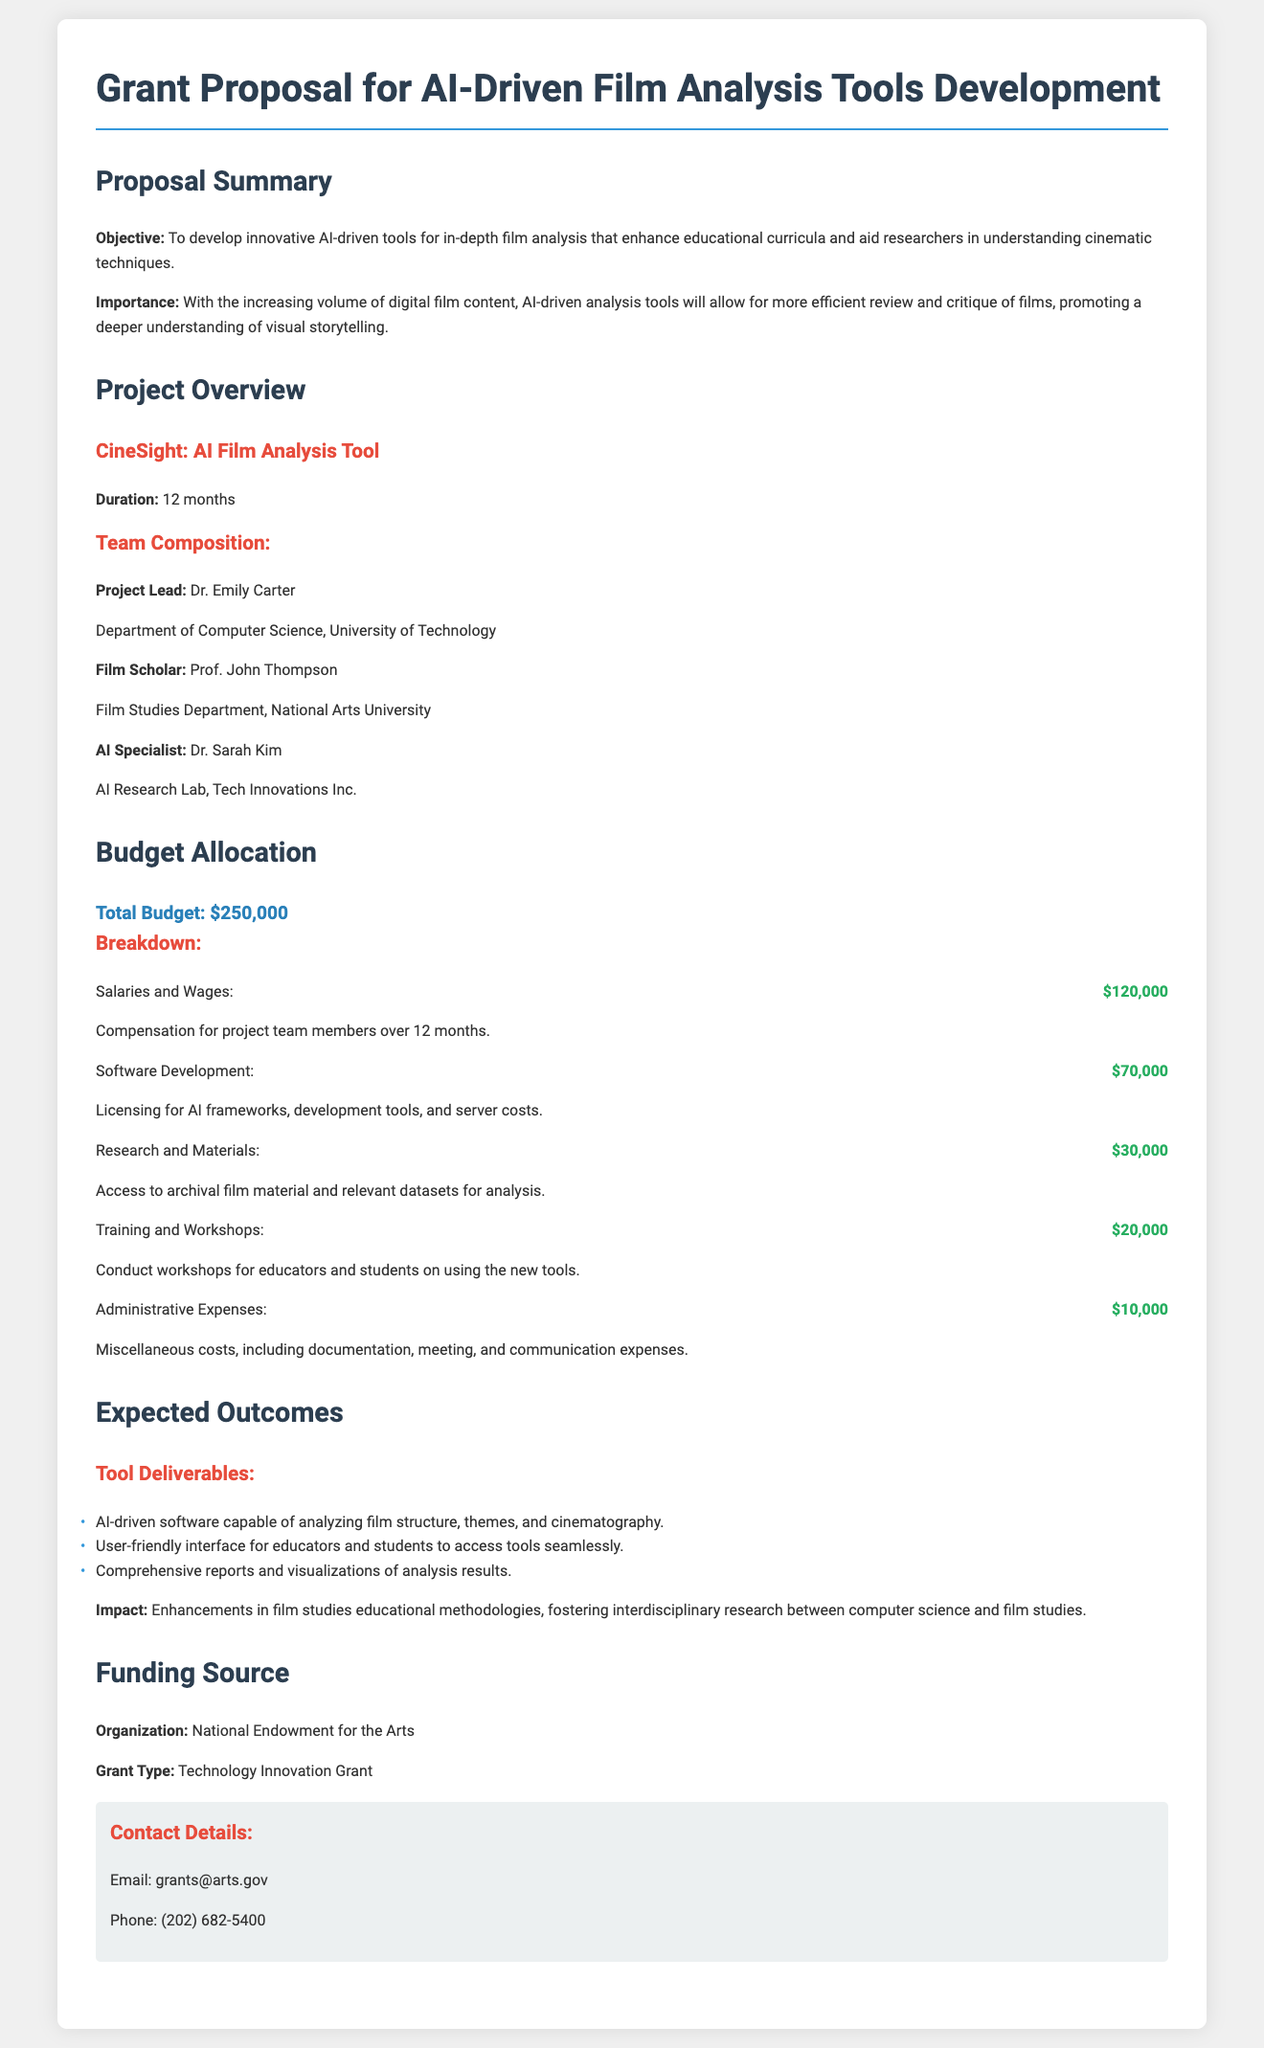What is the total budget requested? The total budget requested is specified in the document as $250,000.
Answer: $250,000 Who is the Project Lead? The document identifies Dr. Emily Carter as the Project Lead.
Answer: Dr. Emily Carter What is the duration of the project? The project duration is stated in the document to be 12 months.
Answer: 12 months How much is allocated for Software Development? The budget allocates $70,000 specifically for Software Development.
Answer: $70,000 Which organization is funding the project? The funding source named in the document is the National Endowment for the Arts.
Answer: National Endowment for the Arts What is one expected outcome of the project? One expected outcome mentioned is the delivery of an AI-driven software capable of analyzing film structure.
Answer: AI-driven software How much will be spent on Training and Workshops? The document specifies a budget of $20,000 for Training and Workshops.
Answer: $20,000 Who is the Film Scholar on the project team? The Film Scholar listed in the document is Prof. John Thompson.
Answer: Prof. John Thompson What type of grant is being sought? The document mentions that the grant type is a Technology Innovation Grant.
Answer: Technology Innovation Grant 